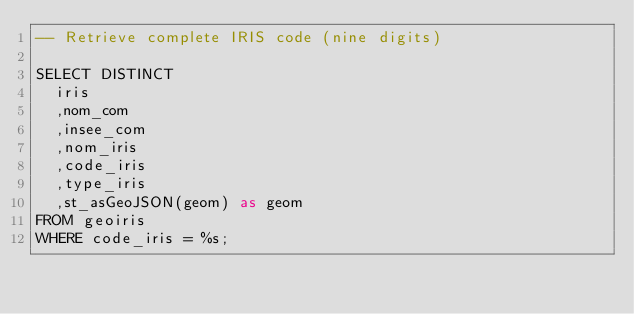<code> <loc_0><loc_0><loc_500><loc_500><_SQL_>-- Retrieve complete IRIS code (nine digits)

SELECT DISTINCT
  iris
  ,nom_com
  ,insee_com
  ,nom_iris
  ,code_iris
  ,type_iris
  ,st_asGeoJSON(geom) as geom
FROM geoiris
WHERE code_iris = %s;
</code> 